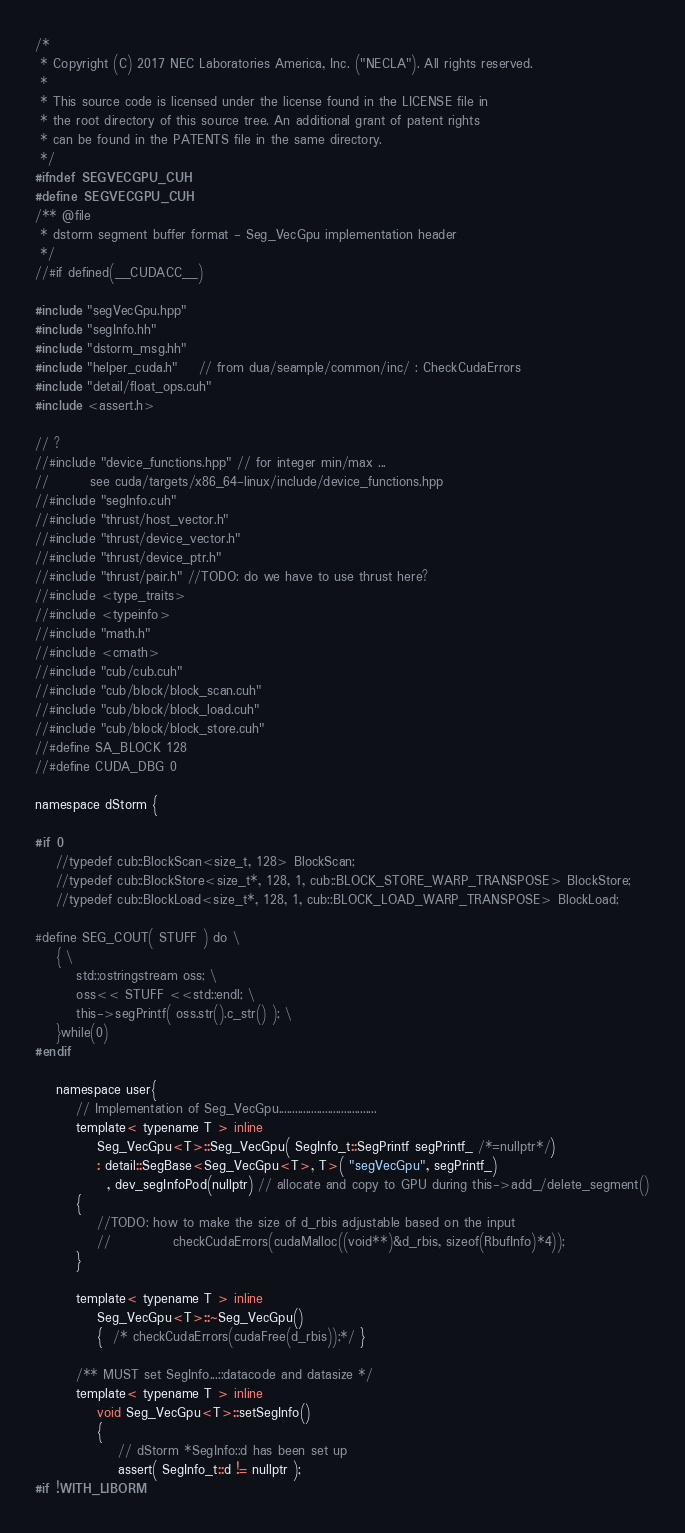Convert code to text. <code><loc_0><loc_0><loc_500><loc_500><_Cuda_>/* 
 * Copyright (C) 2017 NEC Laboratories America, Inc. ("NECLA"). All rights reserved.
 *
 * This source code is licensed under the license found in the LICENSE file in
 * the root directory of this source tree. An additional grant of patent rights
 * can be found in the PATENTS file in the same directory.
 */
#ifndef SEGVECGPU_CUH
#define SEGVECGPU_CUH
/** @file
 * dstorm segment buffer format - Seg_VecGpu implementation header
 */
//#if defined(__CUDACC__)

#include "segVecGpu.hpp"
#include "segInfo.hh"
#include "dstorm_msg.hh"
#include "helper_cuda.h"	// from dua/seample/common/inc/ : CheckCudaErrors
#include "detail/float_ops.cuh"
#include <assert.h>

// ?
//#include "device_functions.hpp" // for integer min/max ...
//        see cuda/targets/x86_64-linux/include/device_functions.hpp
//#include "segInfo.cuh"
//#include "thrust/host_vector.h"
//#include "thrust/device_vector.h"
//#include "thrust/device_ptr.h"
//#include "thrust/pair.h" //TODO: do we have to use thrust here?
//#include <type_traits>
//#include <typeinfo>
//#include "math.h"
//#include <cmath>
//#include "cub/cub.cuh"
//#include "cub/block/block_scan.cuh"
//#include "cub/block/block_load.cuh"
//#include "cub/block/block_store.cuh"
//#define SA_BLOCK 128
//#define CUDA_DBG 0

namespace dStorm {

#if 0
    //typedef cub::BlockScan<size_t, 128> BlockScan;
    //typedef cub::BlockStore<size_t*, 128, 1, cub::BLOCK_STORE_WARP_TRANSPOSE> BlockStore;
    //typedef cub::BlockLoad<size_t*, 128, 1, cub::BLOCK_LOAD_WARP_TRANSPOSE> BlockLoad;

#define SEG_COUT( STUFF ) do \
    { \
        std::ostringstream oss; \
        oss<< STUFF <<std::endl; \
        this->segPrintf( oss.str().c_str() ); \
    }while(0)
#endif

    namespace user{
        // Implementation of Seg_VecGpu....................................
        template< typename T > inline
            Seg_VecGpu<T>::Seg_VecGpu( SegInfo_t::SegPrintf segPrintf_ /*=nullptr*/)
            : detail::SegBase<Seg_VecGpu<T>, T>( "segVecGpu", segPrintf_)
              , dev_segInfoPod(nullptr) // allocate and copy to GPU during this->add_/delete_segment()
        {
            //TODO: how to make the size of d_rbis adjustable based on the input
            //            checkCudaErrors(cudaMalloc((void**)&d_rbis, sizeof(RbufInfo)*4));
        }

        template< typename T > inline
            Seg_VecGpu<T>::~Seg_VecGpu()
            {  /* checkCudaErrors(cudaFree(d_rbis));*/ }

        /** MUST set SegInfo...::datacode and datasize */
        template< typename T > inline
            void Seg_VecGpu<T>::setSegInfo()
            {
                // dStorm *SegInfo::d has been set up
                assert( SegInfo_t::d != nullptr );
#if !WITH_LIBORM</code> 